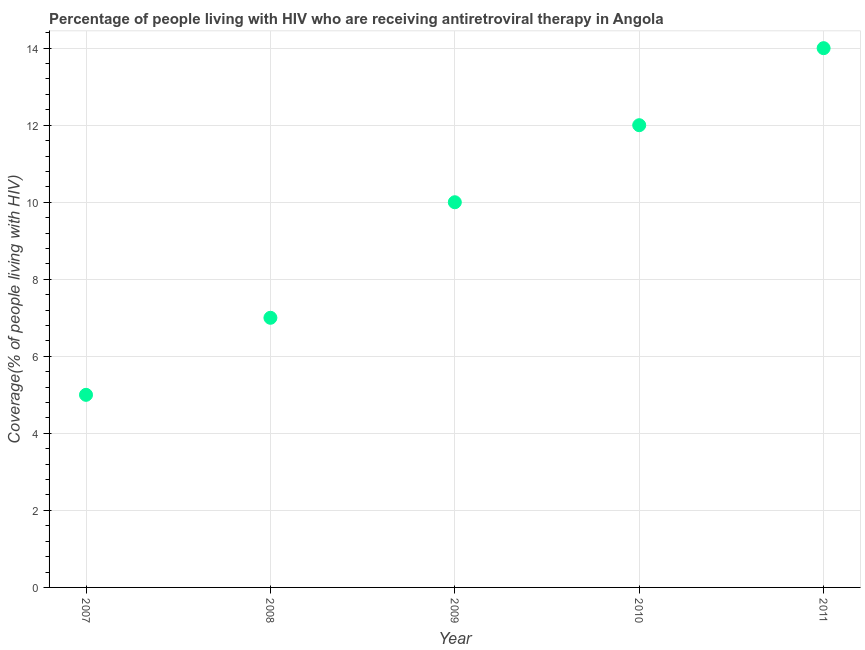What is the antiretroviral therapy coverage in 2007?
Provide a short and direct response. 5. Across all years, what is the maximum antiretroviral therapy coverage?
Provide a succinct answer. 14. Across all years, what is the minimum antiretroviral therapy coverage?
Your answer should be compact. 5. In which year was the antiretroviral therapy coverage maximum?
Provide a succinct answer. 2011. What is the sum of the antiretroviral therapy coverage?
Your answer should be compact. 48. What is the difference between the antiretroviral therapy coverage in 2008 and 2011?
Make the answer very short. -7. What is the ratio of the antiretroviral therapy coverage in 2008 to that in 2011?
Offer a terse response. 0.5. Is the antiretroviral therapy coverage in 2007 less than that in 2010?
Provide a short and direct response. Yes. What is the difference between the highest and the lowest antiretroviral therapy coverage?
Provide a succinct answer. 9. In how many years, is the antiretroviral therapy coverage greater than the average antiretroviral therapy coverage taken over all years?
Keep it short and to the point. 3. Are the values on the major ticks of Y-axis written in scientific E-notation?
Keep it short and to the point. No. What is the title of the graph?
Provide a short and direct response. Percentage of people living with HIV who are receiving antiretroviral therapy in Angola. What is the label or title of the X-axis?
Provide a succinct answer. Year. What is the label or title of the Y-axis?
Provide a short and direct response. Coverage(% of people living with HIV). What is the Coverage(% of people living with HIV) in 2008?
Ensure brevity in your answer.  7. What is the difference between the Coverage(% of people living with HIV) in 2007 and 2009?
Make the answer very short. -5. What is the difference between the Coverage(% of people living with HIV) in 2007 and 2010?
Provide a succinct answer. -7. What is the difference between the Coverage(% of people living with HIV) in 2009 and 2011?
Your answer should be very brief. -4. What is the ratio of the Coverage(% of people living with HIV) in 2007 to that in 2008?
Your answer should be very brief. 0.71. What is the ratio of the Coverage(% of people living with HIV) in 2007 to that in 2009?
Ensure brevity in your answer.  0.5. What is the ratio of the Coverage(% of people living with HIV) in 2007 to that in 2010?
Offer a terse response. 0.42. What is the ratio of the Coverage(% of people living with HIV) in 2007 to that in 2011?
Offer a very short reply. 0.36. What is the ratio of the Coverage(% of people living with HIV) in 2008 to that in 2009?
Ensure brevity in your answer.  0.7. What is the ratio of the Coverage(% of people living with HIV) in 2008 to that in 2010?
Ensure brevity in your answer.  0.58. What is the ratio of the Coverage(% of people living with HIV) in 2009 to that in 2010?
Provide a succinct answer. 0.83. What is the ratio of the Coverage(% of people living with HIV) in 2009 to that in 2011?
Your answer should be compact. 0.71. What is the ratio of the Coverage(% of people living with HIV) in 2010 to that in 2011?
Ensure brevity in your answer.  0.86. 